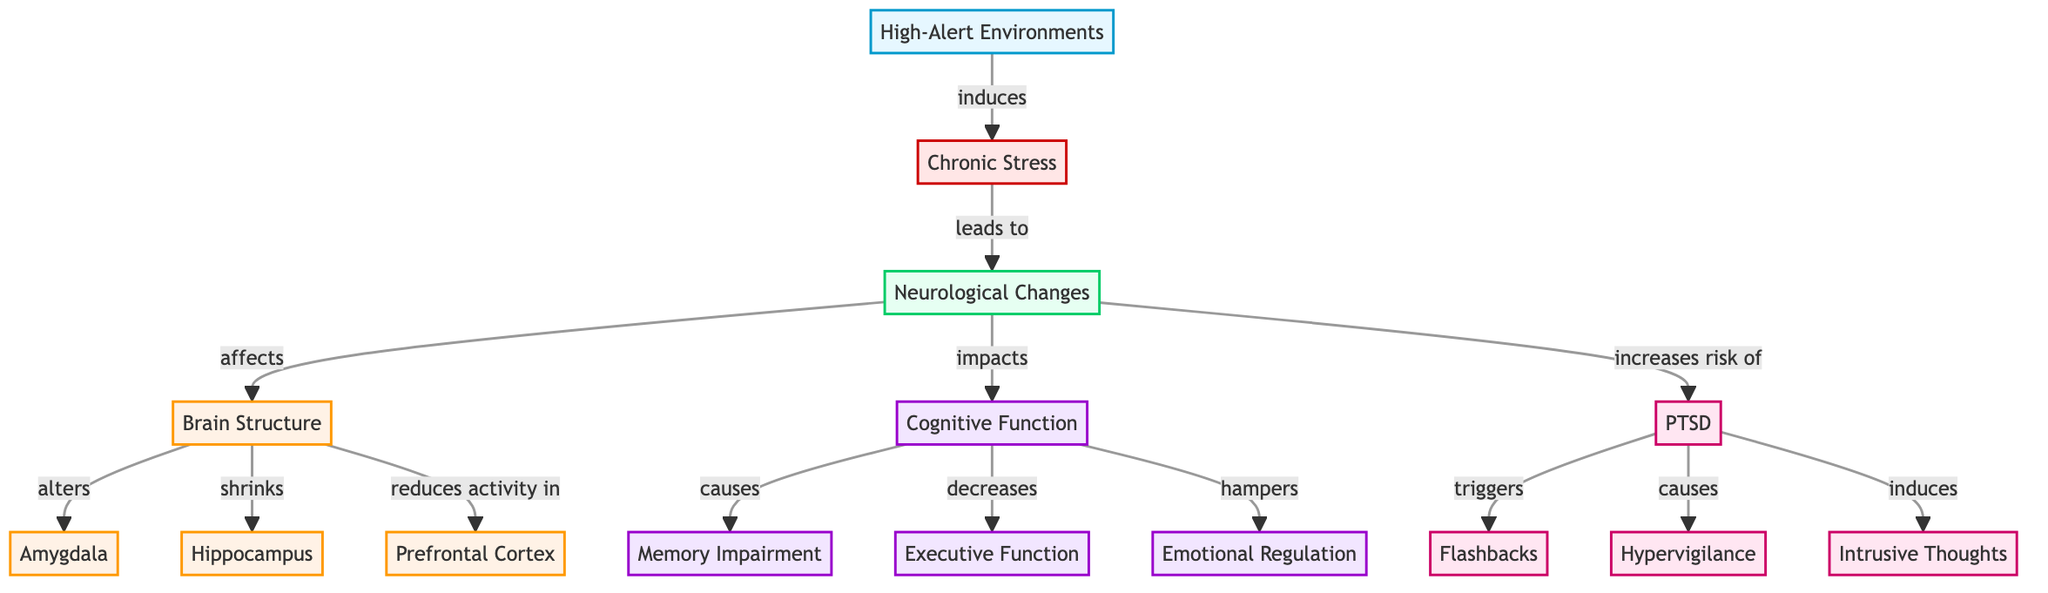What is the first node in the diagram? The first node is labeled "High-Alert Environments," which is the starting point of the flowchart indicating the initial factor affecting Secret Service agents.
Answer: High-Alert Environments How many brain structure nodes are there? There are three nodes related to brain structure: Amygdala, Hippocampus, and Prefrontal Cortex. Counting these nodes gives us the total number of brain structure nodes in the diagram.
Answer: 3 What does chronic stress lead to? According to the diagram, chronic stress leads to neurological changes, indicating that this condition has direct implications on the neurological state of individuals exposed to high-alert environments.
Answer: Neurological Changes Which brain structure is mentioned as being shrunk? The diagram indicates that chronic stress affects brain structure by leading to the shrinking of the Hippocampus specifically, making it clear which structure is impacted in this way.
Answer: Hippocampus What three cognitive functions are impacted by neurological changes? The cognitive functions impacted are Memory Impairment, Executive Function, and Emotional Regulation, as illustrated in the flow of how neurological changes affect cognitive functions in agents.
Answer: Memory Impairment, Executive Function, Emotional Regulation How does PTSD affect emotional responses? PTSD is linked to intrusive thoughts and flashbacks, which disrupt emotional regulation, showing how PTSD can interfere with an agent's emotional response to situations experienced during high-alert environments.
Answer: Disrupts emotional regulation Which node shows the connection between PTSD and hypervigilance? The connection is made explicitly in the flowchart where PTSD leads to hypervigilance, establishing a direct link between the two conditions.
Answer: PTSD to Hypervigilance What are the three symptoms associated with PTSD in the diagram? The symptoms are Flashbacks, Hypervigilance, and Intrusive Thoughts, as depicted in the section concerning PTSD in the diagram, highlighting its effect on agents.
Answer: Flashbacks, Hypervigilance, Intrusive Thoughts How does chronic stress impact cognitive function? Chronic stress impacts cognitive function by causing Memory Impairment, decreasing Executive Function, and hampering Emotional Regulation, revealing the multiple areas where cognitive abilities are affected.
Answer: Memory Impairment, decreases Executive Function, hampers Emotional Regulation 